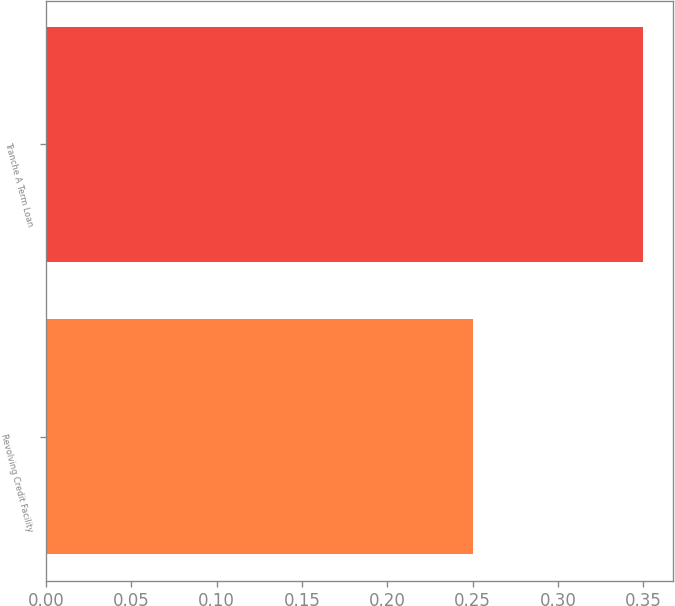Convert chart. <chart><loc_0><loc_0><loc_500><loc_500><bar_chart><fcel>Revolving Credit Facility<fcel>Tranche A Term Loan<nl><fcel>0.25<fcel>0.35<nl></chart> 